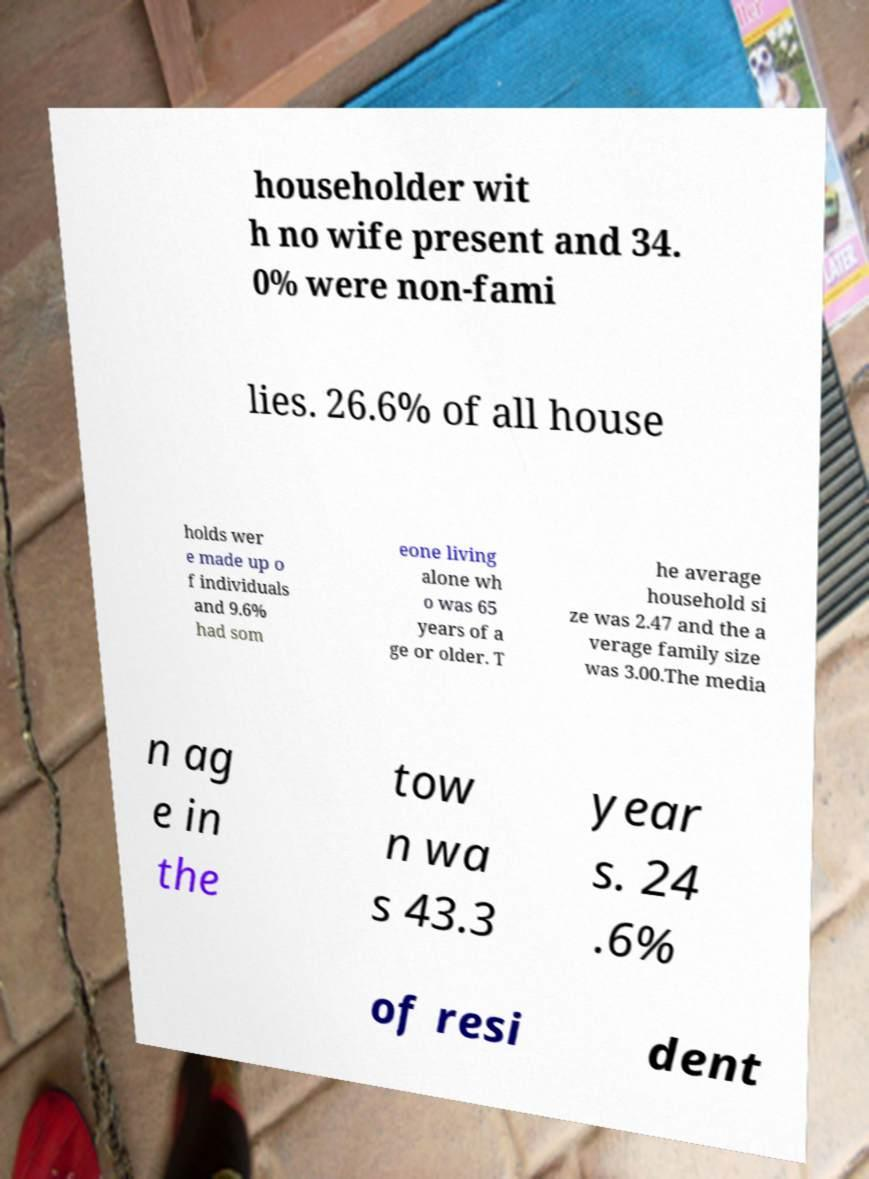There's text embedded in this image that I need extracted. Can you transcribe it verbatim? householder wit h no wife present and 34. 0% were non-fami lies. 26.6% of all house holds wer e made up o f individuals and 9.6% had som eone living alone wh o was 65 years of a ge or older. T he average household si ze was 2.47 and the a verage family size was 3.00.The media n ag e in the tow n wa s 43.3 year s. 24 .6% of resi dent 